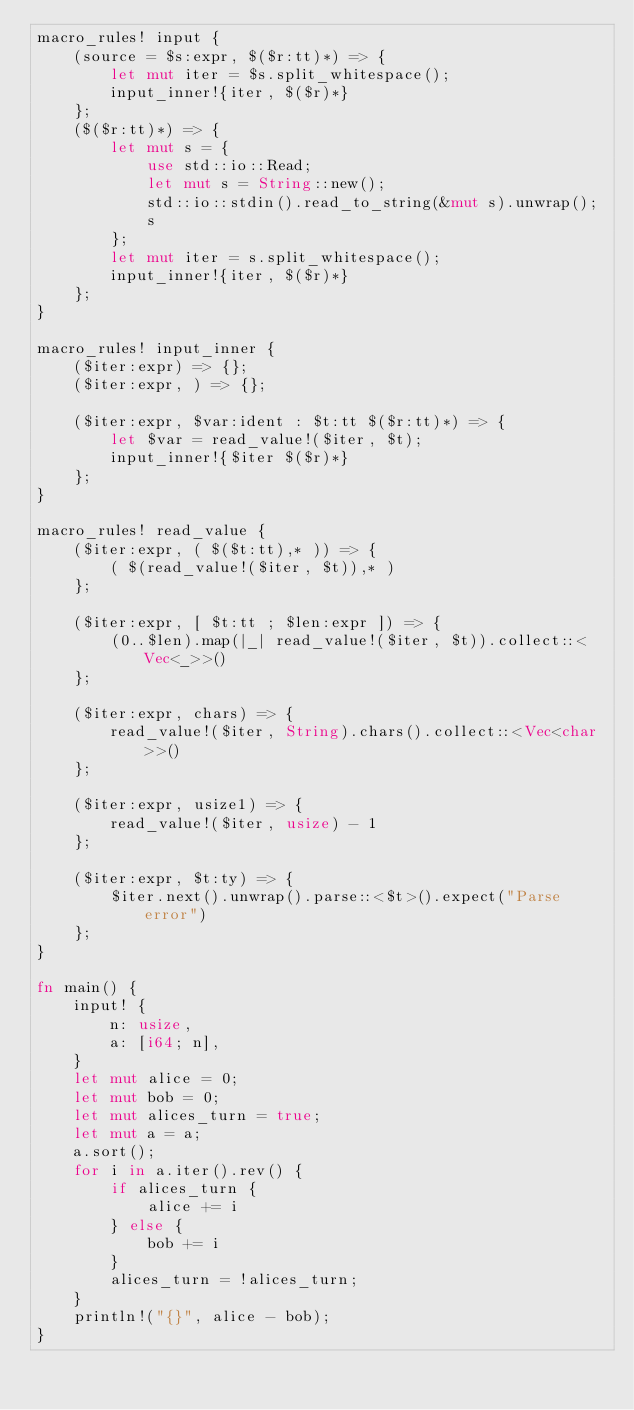<code> <loc_0><loc_0><loc_500><loc_500><_Rust_>macro_rules! input {
    (source = $s:expr, $($r:tt)*) => {
        let mut iter = $s.split_whitespace();
        input_inner!{iter, $($r)*}
    };
    ($($r:tt)*) => {
        let mut s = {
            use std::io::Read;
            let mut s = String::new();
            std::io::stdin().read_to_string(&mut s).unwrap();
            s
        };
        let mut iter = s.split_whitespace();
        input_inner!{iter, $($r)*}
    };
}

macro_rules! input_inner {
    ($iter:expr) => {};
    ($iter:expr, ) => {};

    ($iter:expr, $var:ident : $t:tt $($r:tt)*) => {
        let $var = read_value!($iter, $t);
        input_inner!{$iter $($r)*}
    };
}

macro_rules! read_value {
    ($iter:expr, ( $($t:tt),* )) => {
        ( $(read_value!($iter, $t)),* )
    };

    ($iter:expr, [ $t:tt ; $len:expr ]) => {
        (0..$len).map(|_| read_value!($iter, $t)).collect::<Vec<_>>()
    };

    ($iter:expr, chars) => {
        read_value!($iter, String).chars().collect::<Vec<char>>()
    };

    ($iter:expr, usize1) => {
        read_value!($iter, usize) - 1
    };

    ($iter:expr, $t:ty) => {
        $iter.next().unwrap().parse::<$t>().expect("Parse error")
    };
}

fn main() {
    input! {
        n: usize,
        a: [i64; n],
    }
    let mut alice = 0;
    let mut bob = 0;
    let mut alices_turn = true;
    let mut a = a;
    a.sort();
    for i in a.iter().rev() {
        if alices_turn {
            alice += i
        } else {
            bob += i
        }
        alices_turn = !alices_turn;
    }
    println!("{}", alice - bob);
}
</code> 